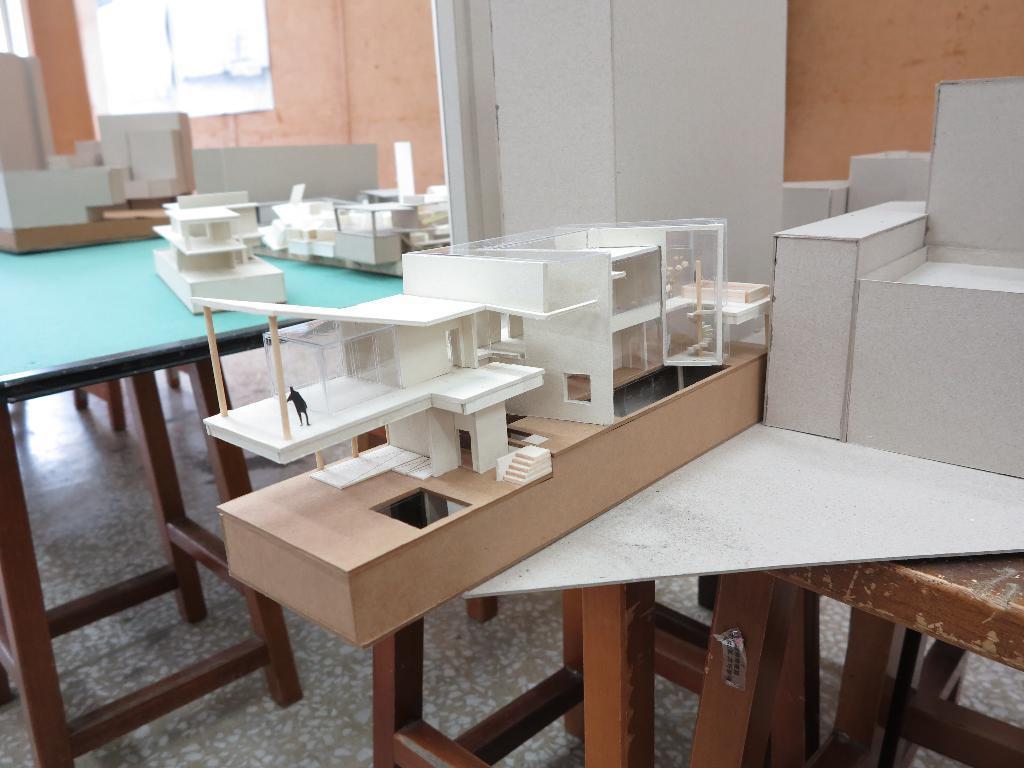Can you describe this image briefly? In this picture we can see few miniatures on the tables. 